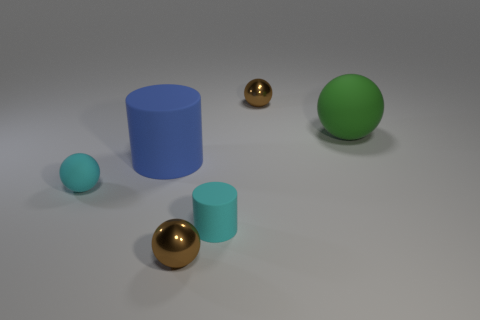There is a cyan cylinder that is made of the same material as the blue thing; what is its size?
Ensure brevity in your answer.  Small. Are there any small cyan matte objects to the left of the small cyan ball?
Offer a terse response. No. Do the big green object and the blue rubber thing have the same shape?
Make the answer very short. No. There is a rubber cylinder that is to the left of the tiny brown object left of the cylinder to the right of the big blue matte cylinder; what is its size?
Make the answer very short. Large. There is a matte cylinder that is the same color as the tiny rubber sphere; what size is it?
Your response must be concise. Small. There is a large blue rubber object; is it the same shape as the tiny metal object in front of the tiny cyan matte cylinder?
Your response must be concise. No. There is a thing that is on the right side of the small metallic thing that is behind the sphere in front of the tiny cyan cylinder; what is its material?
Keep it short and to the point. Rubber. What number of purple metal blocks are there?
Your answer should be compact. 0. What number of blue objects are either cylinders or small cylinders?
Ensure brevity in your answer.  1. What number of other things are the same shape as the green matte object?
Your answer should be compact. 3. 